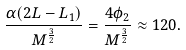Convert formula to latex. <formula><loc_0><loc_0><loc_500><loc_500>\frac { \alpha ( 2 L - L _ { 1 } ) } { M ^ { \frac { 3 } { 2 } } } = \frac { 4 \phi _ { 2 } } { M ^ { \frac { 3 } { 2 } } } \approx 1 2 0 .</formula> 